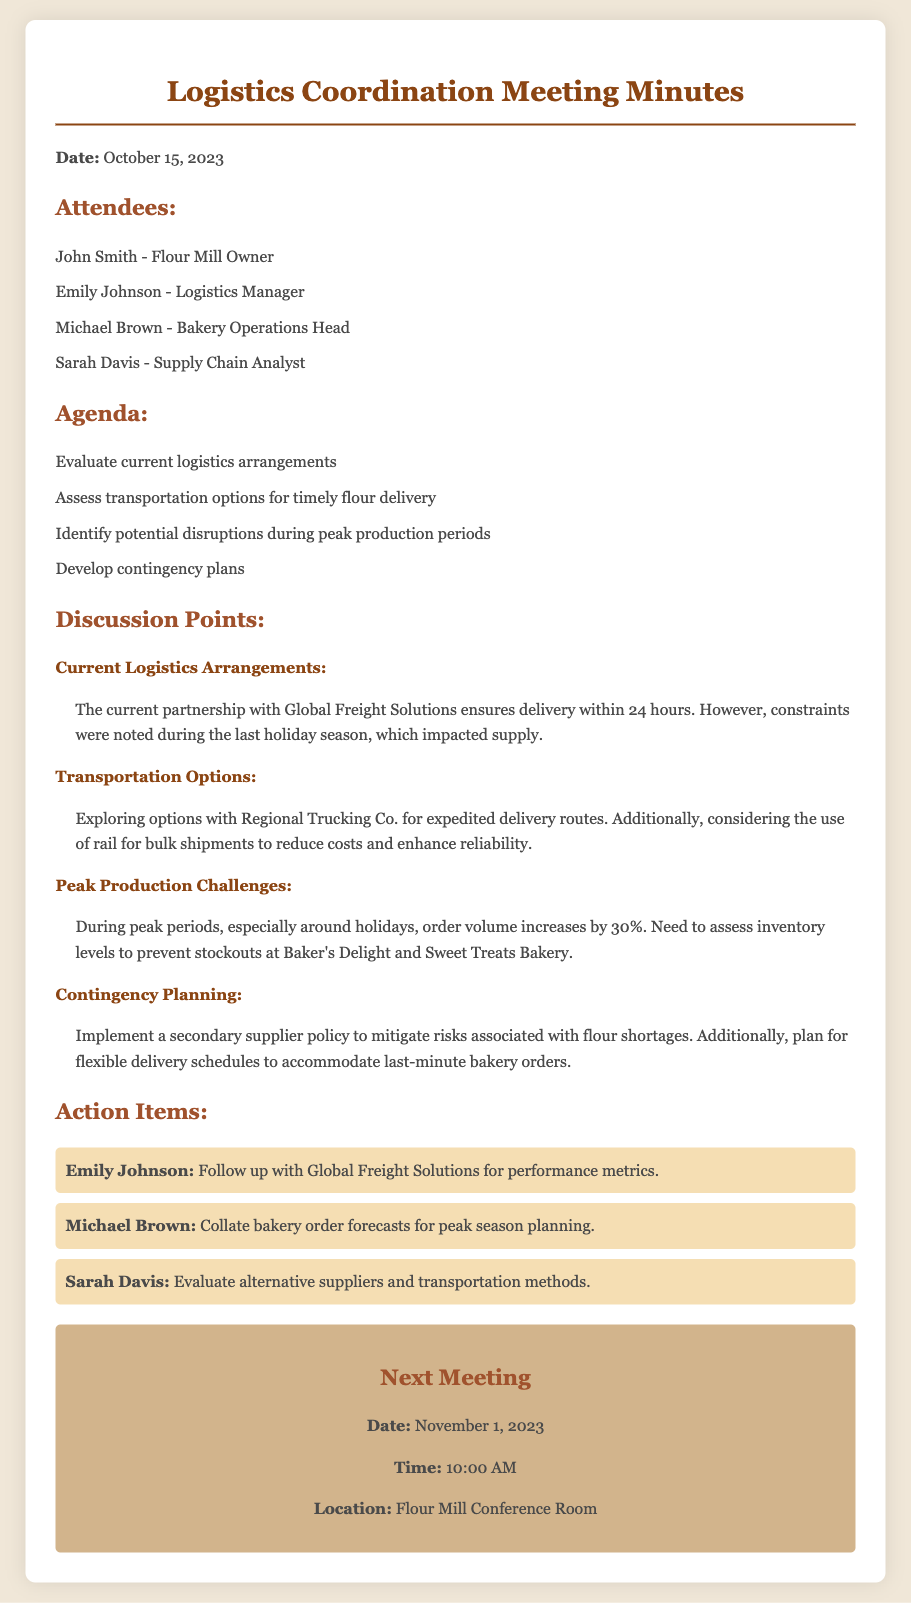What is the date of the meeting? The date of the meeting is mentioned at the beginning of the document under the "Date" section.
Answer: October 15, 2023 Who is the Logistics Manager? The Logistics Manager is listed among the attendees in the document.
Answer: Emily Johnson What transportation company is being explored for expedited delivery routes? This information can be found in the discussion points about transportation options.
Answer: Regional Trucking Co What is the increase in order volume during peak periods? The specific increase in order volume is stated in the discussion points about peak production challenges.
Answer: 30% What contingency plan is proposed to mitigate flour shortages? This detail can be found in the contingency planning section of the discussion points.
Answer: Secondary supplier policy Who is responsible for evaluating alternative suppliers and transportation methods? The action items specify who has been assigned which tasks.
Answer: Sarah Davis What is the location of the next meeting? The location of the next meeting is provided in the "Next Meeting" section.
Answer: Flour Mill Conference Room How often does the current partnership with Global Freight Solutions ensure delivery? This detail is mentioned in the discussion about current logistics arrangements.
Answer: Within 24 hours What does Michael Brown need to collate for peak season planning? The action items specify what Michael Brown's next task is.
Answer: Bakery order forecasts 